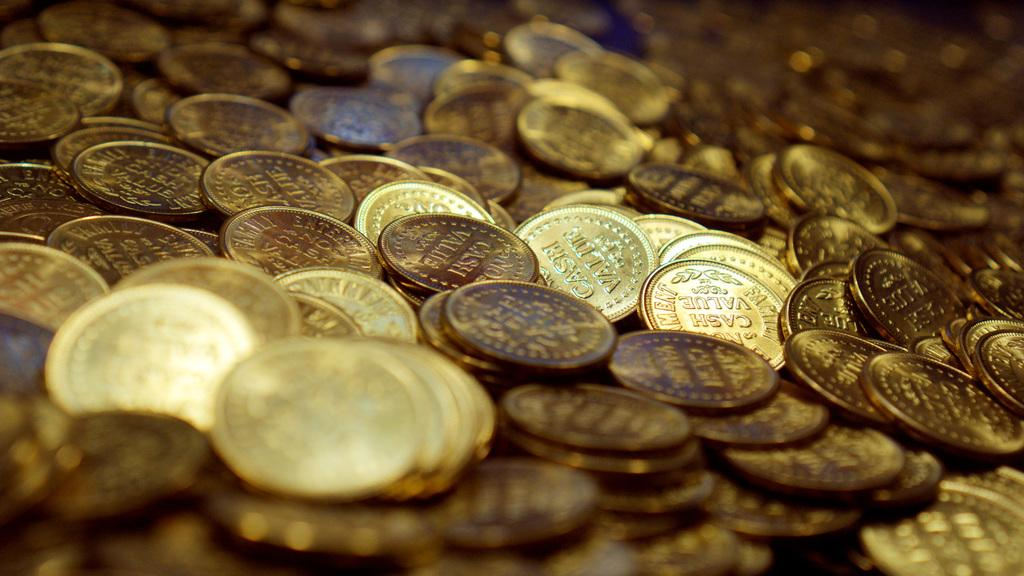<image>
Create a compact narrative representing the image presented. Several gold-colored coins read "no cash value" on them. 